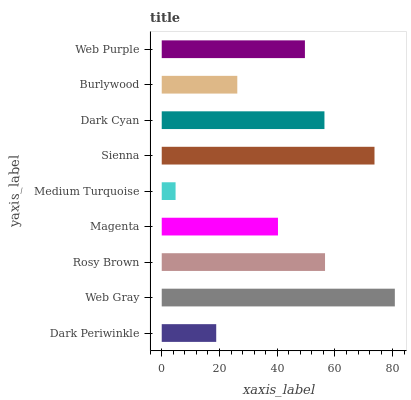Is Medium Turquoise the minimum?
Answer yes or no. Yes. Is Web Gray the maximum?
Answer yes or no. Yes. Is Rosy Brown the minimum?
Answer yes or no. No. Is Rosy Brown the maximum?
Answer yes or no. No. Is Web Gray greater than Rosy Brown?
Answer yes or no. Yes. Is Rosy Brown less than Web Gray?
Answer yes or no. Yes. Is Rosy Brown greater than Web Gray?
Answer yes or no. No. Is Web Gray less than Rosy Brown?
Answer yes or no. No. Is Web Purple the high median?
Answer yes or no. Yes. Is Web Purple the low median?
Answer yes or no. Yes. Is Medium Turquoise the high median?
Answer yes or no. No. Is Rosy Brown the low median?
Answer yes or no. No. 